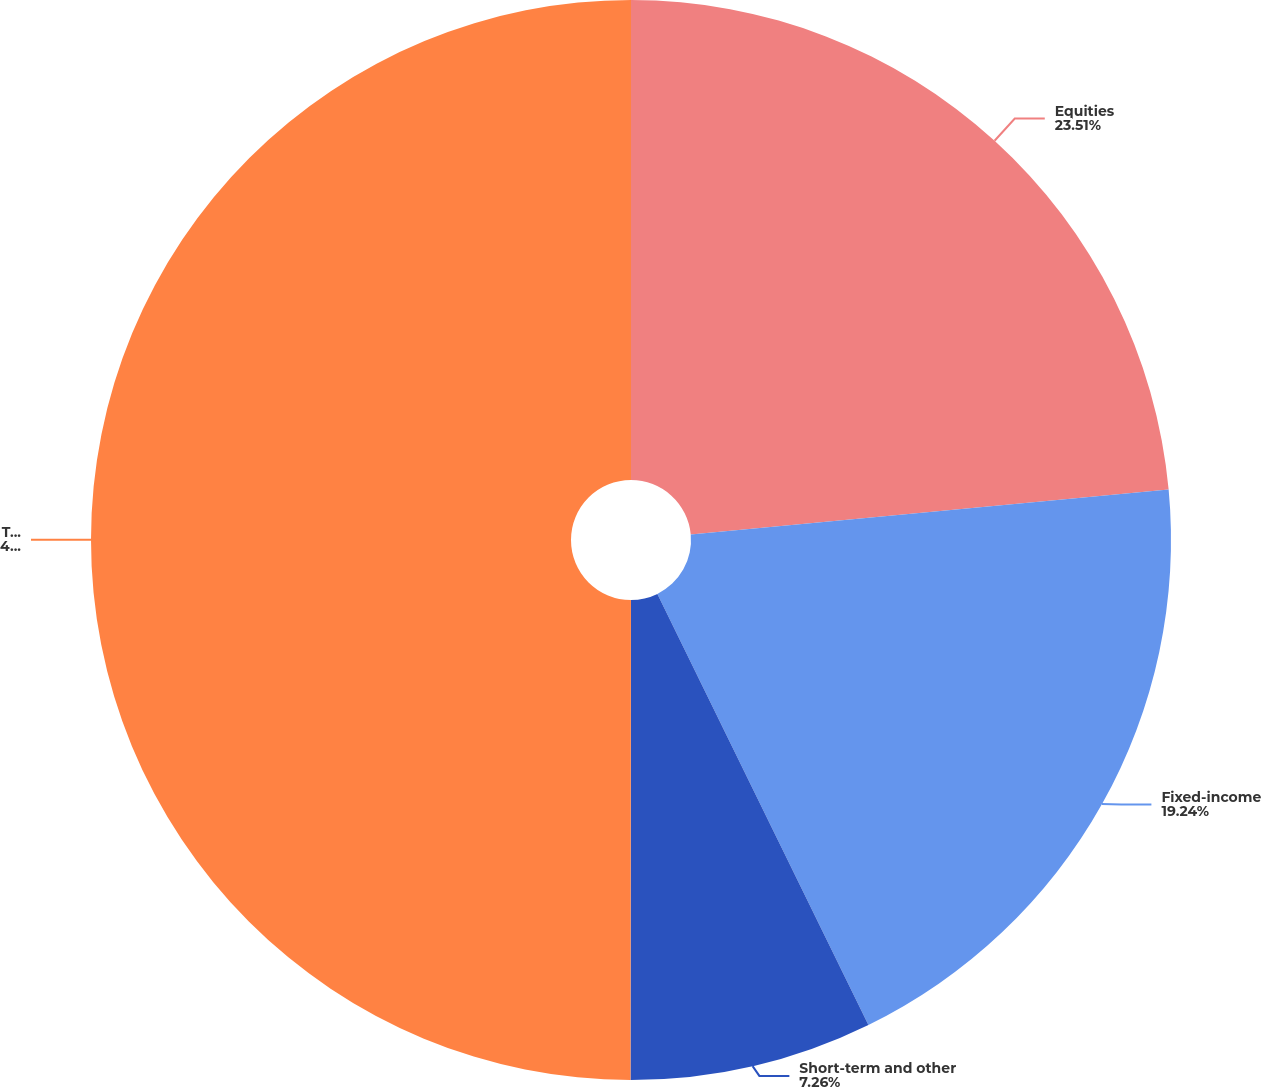Convert chart to OTSL. <chart><loc_0><loc_0><loc_500><loc_500><pie_chart><fcel>Equities<fcel>Fixed-income<fcel>Short-term and other<fcel>Total<nl><fcel>23.51%<fcel>19.24%<fcel>7.26%<fcel>49.98%<nl></chart> 